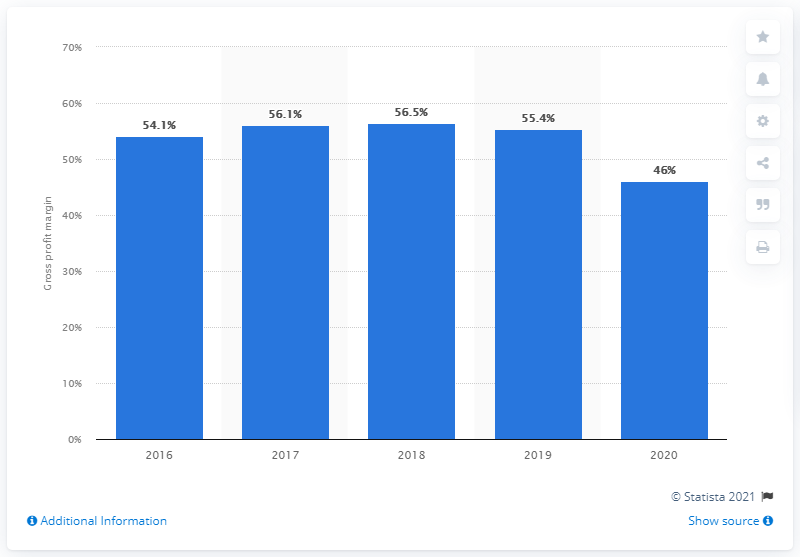Specify some key components in this picture. The gross profit margin of Samsonite in 2020 was 46%. 